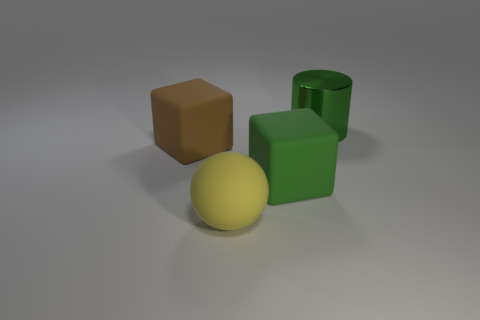Are the large green cylinder and the large yellow thing made of the same material?
Your answer should be very brief. No. Are there any other things that are made of the same material as the cylinder?
Your answer should be very brief. No. There is a large green object that is the same shape as the brown object; what is it made of?
Provide a short and direct response. Rubber. Are there fewer matte cubes in front of the green cube than gray matte objects?
Make the answer very short. No. How many green blocks are behind the yellow matte sphere?
Your answer should be compact. 1. There is a green object to the left of the large cylinder; does it have the same shape as the large matte object to the left of the big ball?
Provide a short and direct response. Yes. What shape is the big object that is to the right of the yellow thing and behind the green matte cube?
Your answer should be compact. Cylinder. What size is the green cube that is the same material as the yellow thing?
Keep it short and to the point. Large. Are there fewer large purple objects than large cylinders?
Provide a succinct answer. Yes. What material is the big yellow ball right of the block that is on the left side of the green object that is in front of the large cylinder made of?
Offer a terse response. Rubber. 